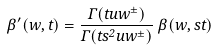<formula> <loc_0><loc_0><loc_500><loc_500>\beta ^ { \prime } ( w , t ) = \frac { \Gamma ( t u w ^ { \pm } ) } { \Gamma ( t s ^ { 2 } u w ^ { \pm } ) } \, \beta ( w , s t )</formula> 